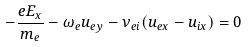<formula> <loc_0><loc_0><loc_500><loc_500>- \frac { e E _ { x } } { m _ { e } } - \omega _ { e } u _ { e y } - \nu _ { e i } ( u _ { e x } - u _ { i x } ) = 0</formula> 